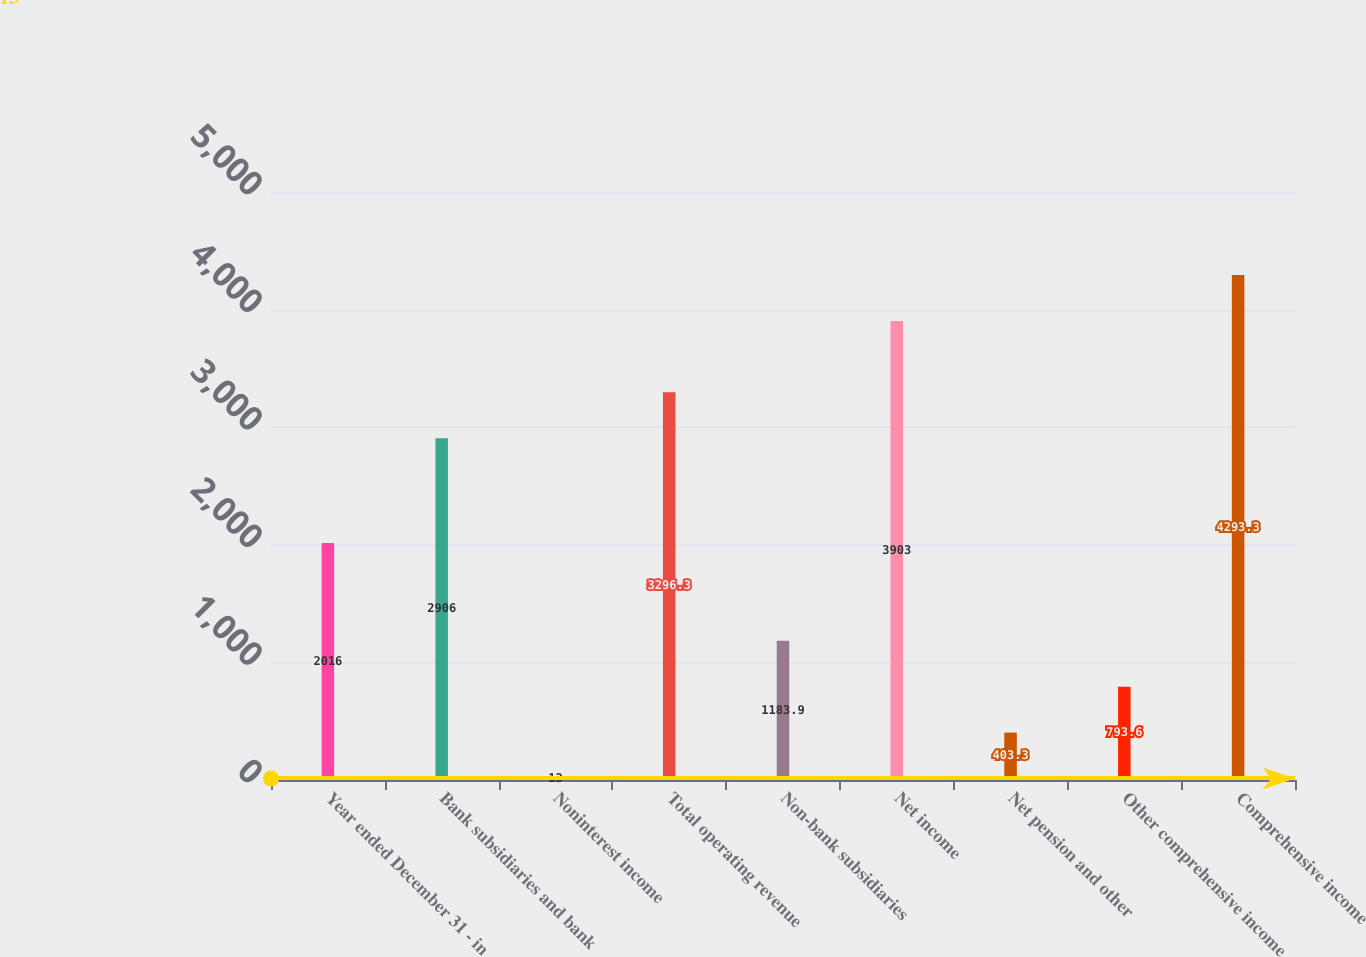Convert chart to OTSL. <chart><loc_0><loc_0><loc_500><loc_500><bar_chart><fcel>Year ended December 31 - in<fcel>Bank subsidiaries and bank<fcel>Noninterest income<fcel>Total operating revenue<fcel>Non-bank subsidiaries<fcel>Net income<fcel>Net pension and other<fcel>Other comprehensive income<fcel>Comprehensive income<nl><fcel>2016<fcel>2906<fcel>13<fcel>3296.3<fcel>1183.9<fcel>3903<fcel>403.3<fcel>793.6<fcel>4293.3<nl></chart> 